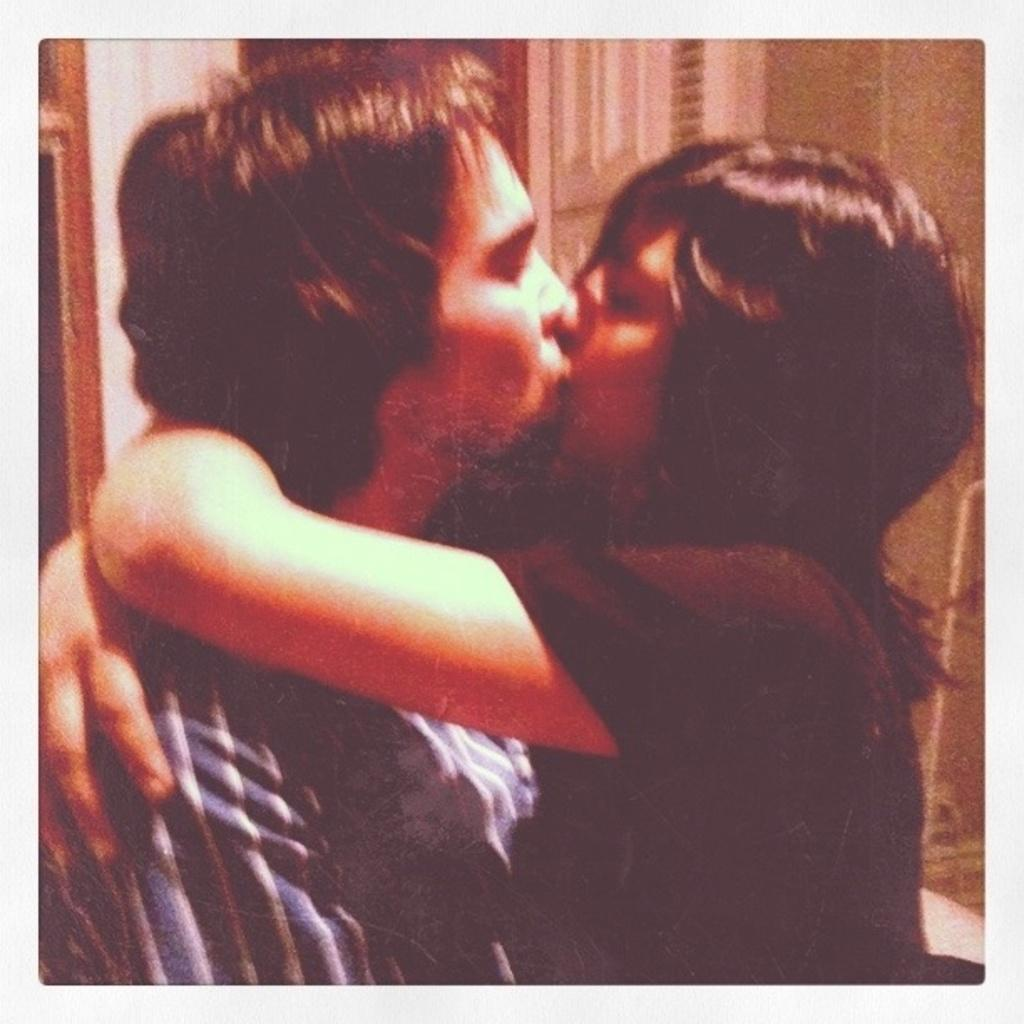What are the two people in the image doing? The two people in the image are kissing. Can you describe the background of the image? The background of the image is blurry. Are there any objects visible in the background? Yes, there are objects in the background of the image. What is the cause of death for the person in the office in the image? There is no person in an office or any indication of death in the image; it features two people kissing with a blurry background. 